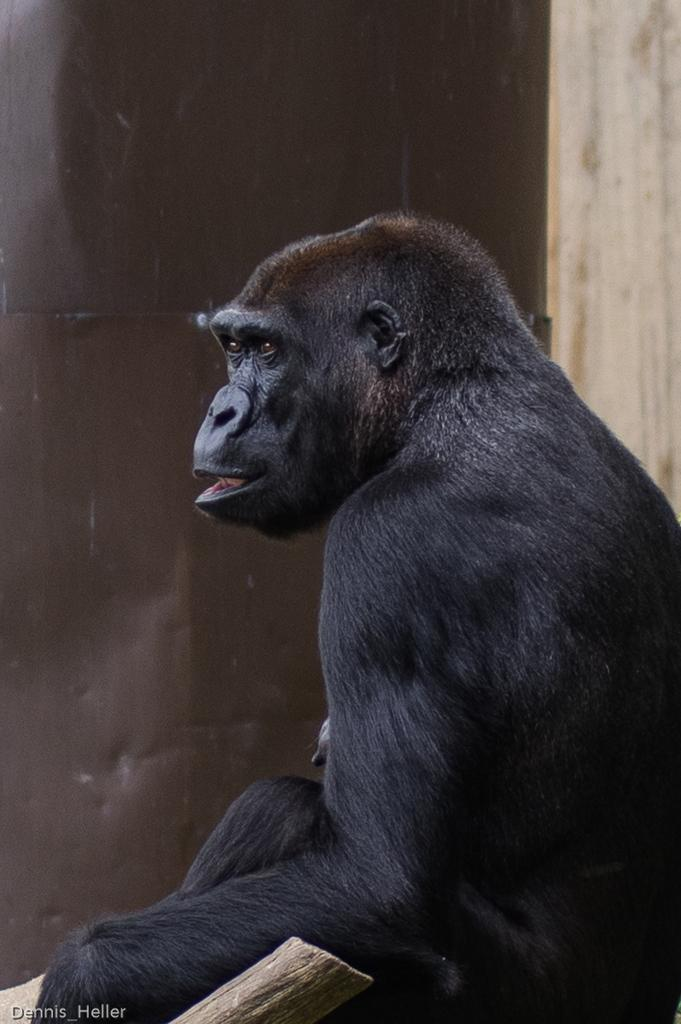What type of animal is in the image? There is a chimpanzee in the image. What is written or displayed at the bottom of the image? There is text at the bottom of the image. What object can be seen in the image besides the chimpanzee? There is a wood log in the image. What can be seen in the background of the image? There is a wall in the background of the image. Can you see a ghost interacting with the chimpanzee in the image? No, there is no ghost present in the image. 